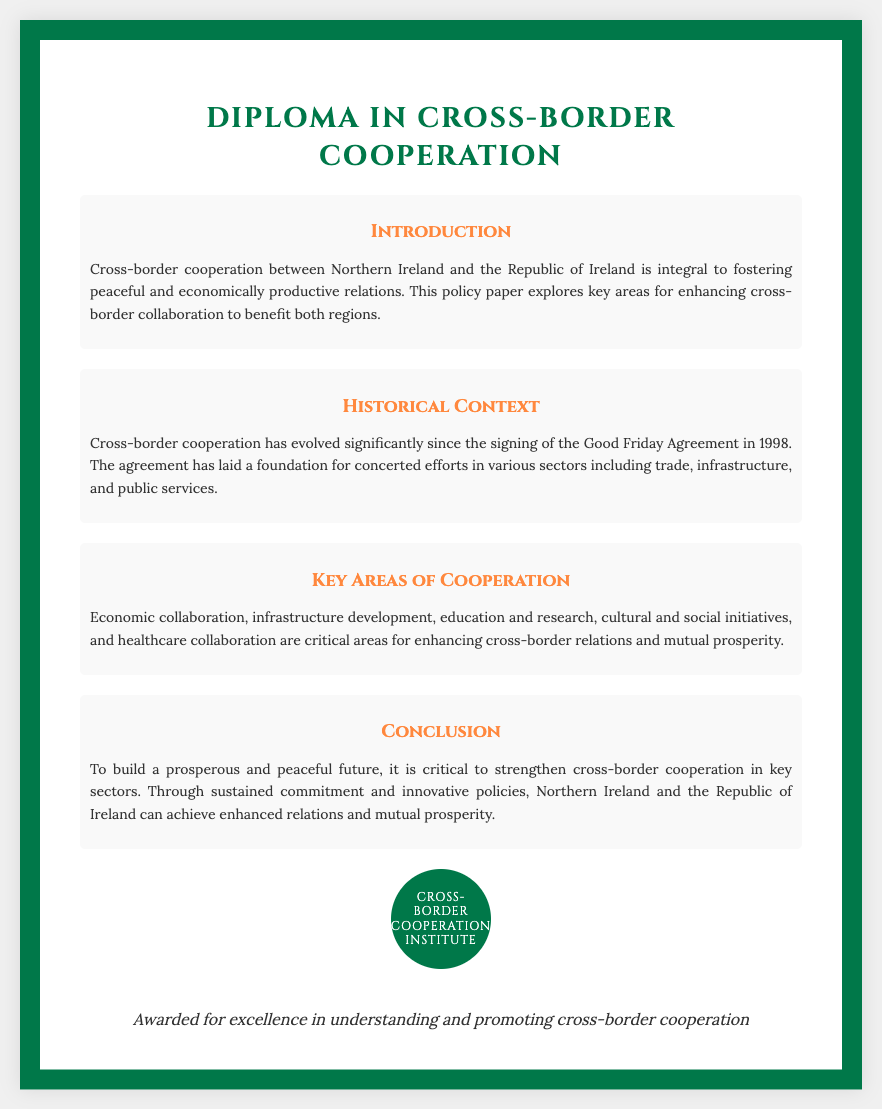What is the title of the diploma? The title is explicitly stated at the top of the document as "Diploma in Cross-Border Cooperation".
Answer: Diploma in Cross-Border Cooperation What year was the Good Friday Agreement signed? The document mentions that the Good Friday Agreement was signed in 1998.
Answer: 1998 What is a critical area for enhancing cross-border relations mentioned in the document? The document lists several areas, one being "economic collaboration".
Answer: Economic collaboration What is the main focus of the policy paper? The introduction section indicates that the main focus is on enhancing cross-border cooperation.
Answer: Enhancing cross-border cooperation Who is awarded the diploma? The document states it is awarded for excellence in understanding and promoting cross-border cooperation.
Answer: Awarded for excellence in understanding and promoting cross-border cooperation What organization is mentioned in the diploma seal? The diploma seal states "Cross-Border Cooperation Institute".
Answer: Cross-Border Cooperation Institute What is emphasized as necessary for a prosperous future? The conclusion of the document emphasizes the need to strengthen cross-border cooperation.
Answer: Strengthen cross-border cooperation What color is the border of the diploma? The document notes that the border color is green, specifically "#007849".
Answer: Green What type of initiatives are included as a key area of cooperation? One type of initiative mentioned is "cultural and social initiatives".
Answer: Cultural and social initiatives 